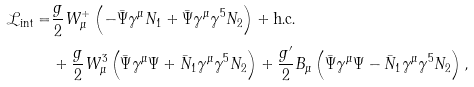Convert formula to latex. <formula><loc_0><loc_0><loc_500><loc_500>\mathcal { L } _ { \text {int} } = & \frac { g } { 2 } W _ { \mu } ^ { + } \left ( - \bar { \Psi } \gamma ^ { \mu } N _ { 1 } + \bar { \Psi } \gamma ^ { \mu } \gamma ^ { 5 } N _ { 2 } \right ) + \text {h.c.} \\ & + \frac { g } { 2 } W _ { \mu } ^ { 3 } \left ( \bar { \Psi } \gamma ^ { \mu } \Psi + \bar { N } _ { 1 } \gamma ^ { \mu } \gamma ^ { 5 } N _ { 2 } \right ) + \frac { g ^ { \prime } } { 2 } B _ { \mu } \left ( \bar { \Psi } \gamma ^ { \mu } \Psi - \bar { N } _ { 1 } \gamma ^ { \mu } \gamma ^ { 5 } N _ { 2 } \right ) ,</formula> 